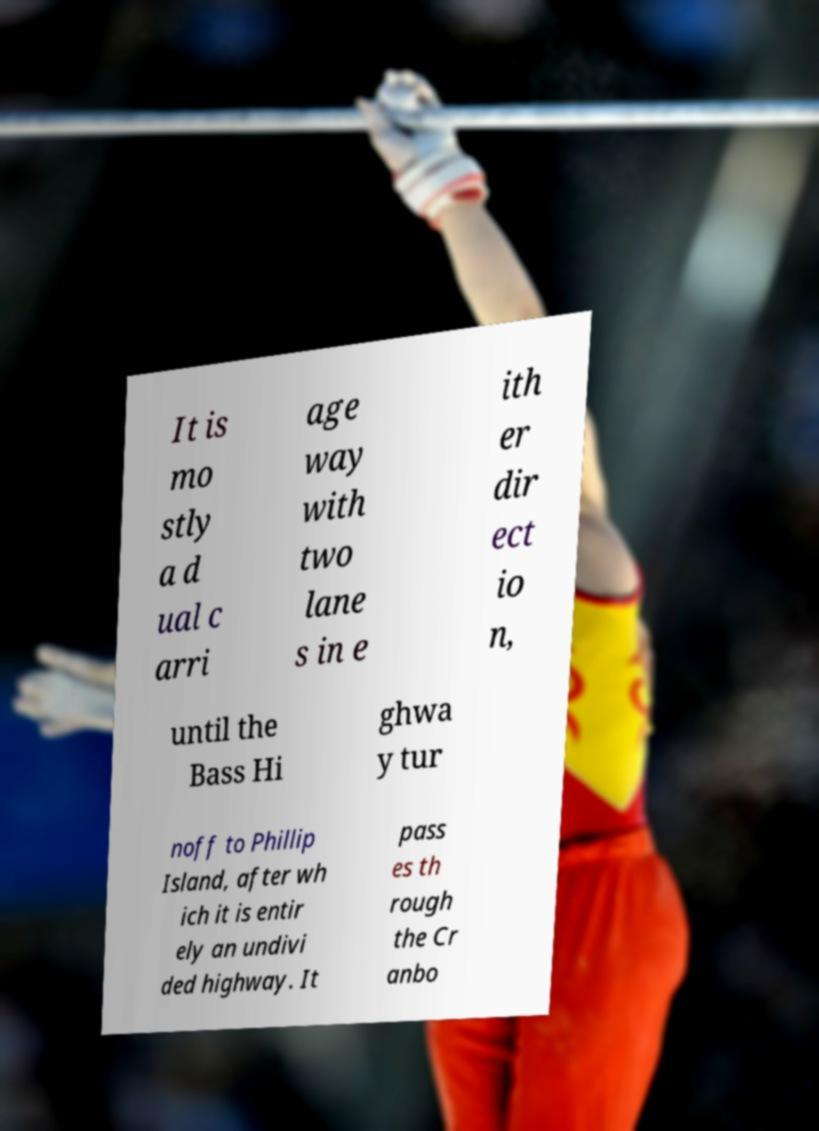Could you extract and type out the text from this image? It is mo stly a d ual c arri age way with two lane s in e ith er dir ect io n, until the Bass Hi ghwa y tur noff to Phillip Island, after wh ich it is entir ely an undivi ded highway. It pass es th rough the Cr anbo 